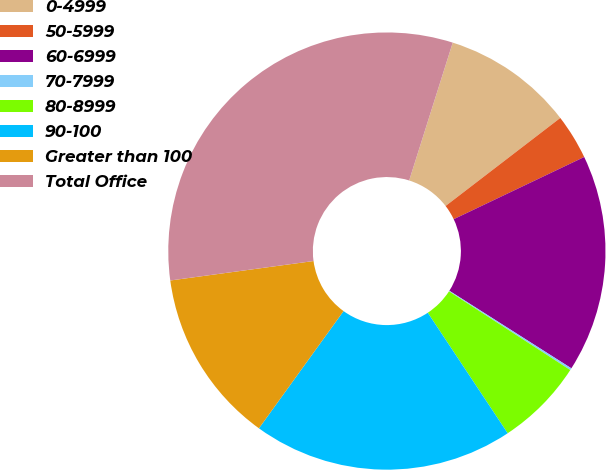Convert chart. <chart><loc_0><loc_0><loc_500><loc_500><pie_chart><fcel>0-4999<fcel>50-5999<fcel>60-6999<fcel>70-7999<fcel>80-8999<fcel>90-100<fcel>Greater than 100<fcel>Total Office<nl><fcel>9.71%<fcel>3.34%<fcel>16.09%<fcel>0.15%<fcel>6.52%<fcel>19.27%<fcel>12.9%<fcel>32.02%<nl></chart> 